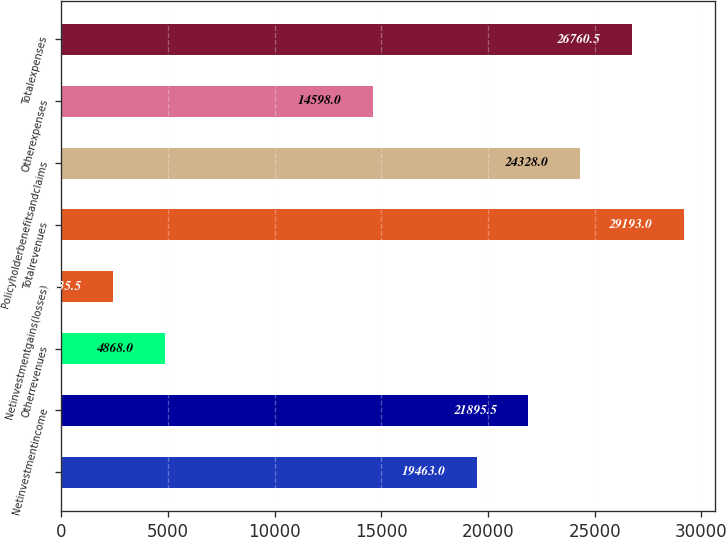Convert chart. <chart><loc_0><loc_0><loc_500><loc_500><bar_chart><ecel><fcel>Netinvestmentincome<fcel>Otherrevenues<fcel>Netinvestmentgains(losses)<fcel>Totalrevenues<fcel>Policyholderbenefitsandclaims<fcel>Otherexpenses<fcel>Totalexpenses<nl><fcel>19463<fcel>21895.5<fcel>4868<fcel>2435.5<fcel>29193<fcel>24328<fcel>14598<fcel>26760.5<nl></chart> 